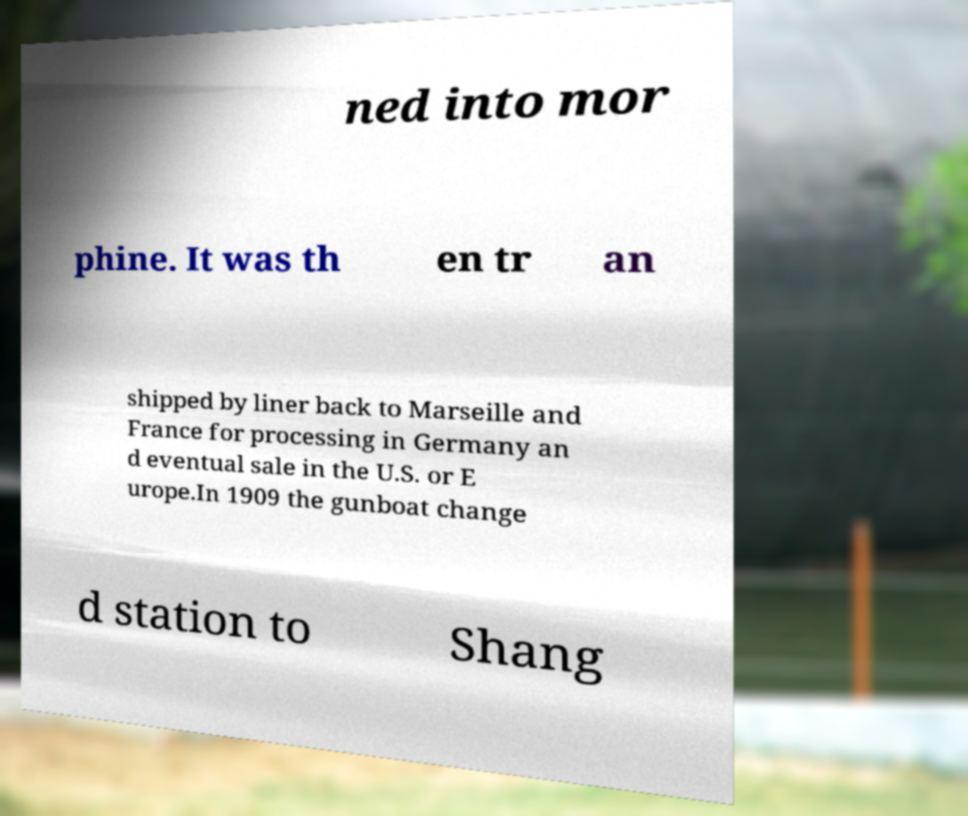Can you accurately transcribe the text from the provided image for me? ned into mor phine. It was th en tr an shipped by liner back to Marseille and France for processing in Germany an d eventual sale in the U.S. or E urope.In 1909 the gunboat change d station to Shang 